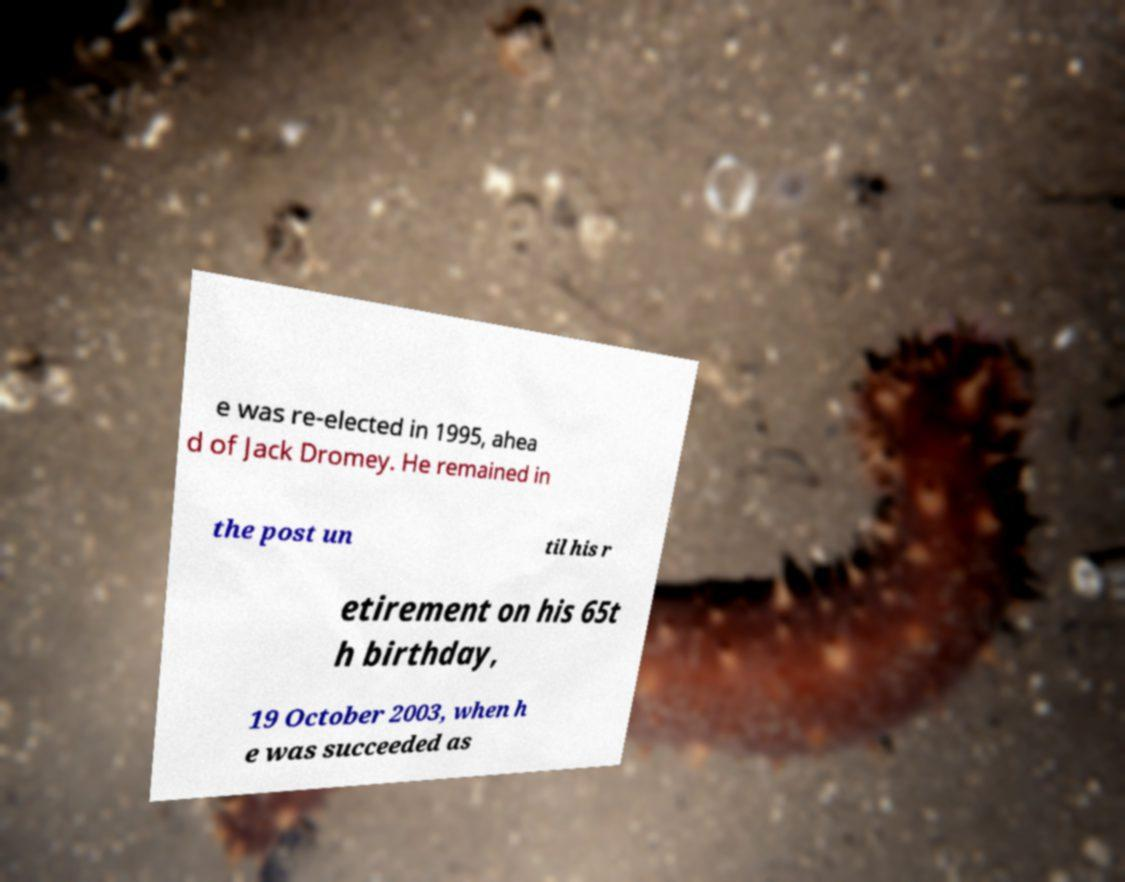What messages or text are displayed in this image? I need them in a readable, typed format. e was re-elected in 1995, ahea d of Jack Dromey. He remained in the post un til his r etirement on his 65t h birthday, 19 October 2003, when h e was succeeded as 